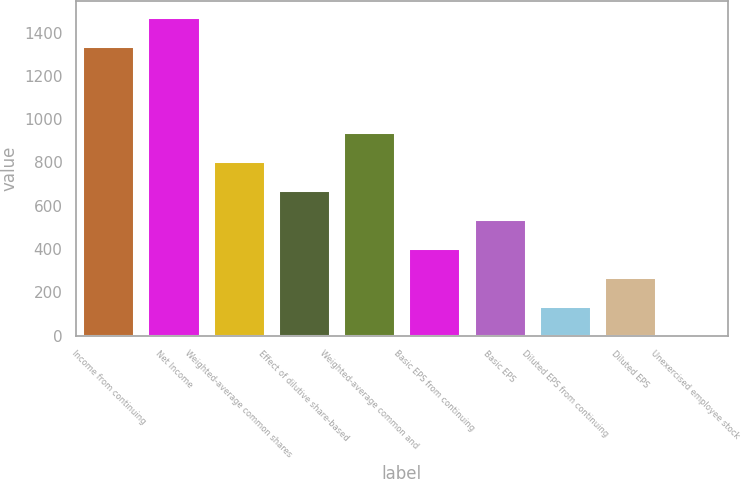Convert chart. <chart><loc_0><loc_0><loc_500><loc_500><bar_chart><fcel>Income from continuing<fcel>Net Income<fcel>Weighted-average common shares<fcel>Effect of dilutive share-based<fcel>Weighted-average common and<fcel>Basic EPS from continuing<fcel>Basic EPS<fcel>Diluted EPS from continuing<fcel>Diluted EPS<fcel>Unexercised employee stock<nl><fcel>1340<fcel>1473.77<fcel>804.92<fcel>671.15<fcel>938.69<fcel>403.61<fcel>537.38<fcel>136.07<fcel>269.84<fcel>2.3<nl></chart> 